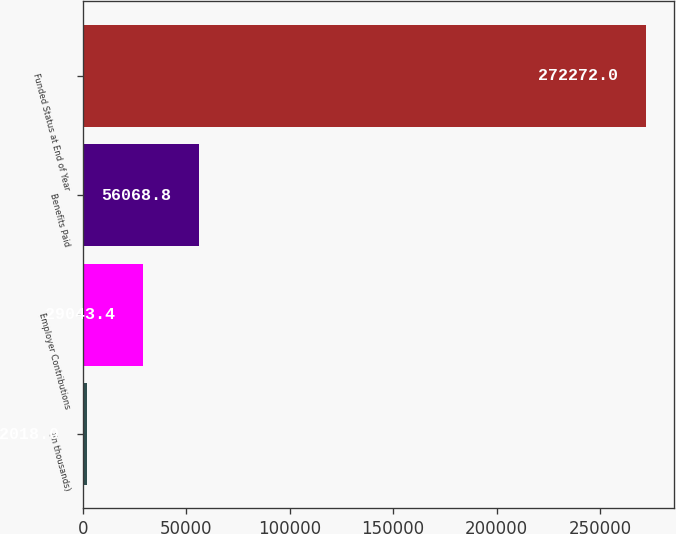Convert chart. <chart><loc_0><loc_0><loc_500><loc_500><bar_chart><fcel>(in thousands)<fcel>Employer Contributions<fcel>Benefits Paid<fcel>Funded Status at End of Year<nl><fcel>2018<fcel>29043.4<fcel>56068.8<fcel>272272<nl></chart> 